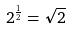Convert formula to latex. <formula><loc_0><loc_0><loc_500><loc_500>2 ^ { \frac { 1 } { 2 } } = \sqrt { 2 }</formula> 